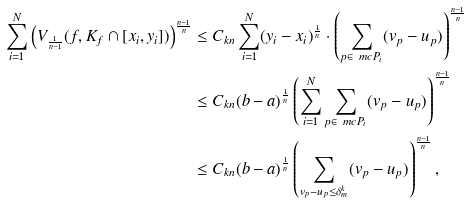<formula> <loc_0><loc_0><loc_500><loc_500>\sum ^ { N } _ { i = 1 } \left ( V _ { \frac { 1 } { n - 1 } } ( f , K _ { f } \cap [ x _ { i } , y _ { i } ] ) \right ) ^ { \frac { n - 1 } { n } } & \leq C _ { k n } \sum ^ { N } _ { i = 1 } ( y _ { i } - x _ { i } ) ^ { \frac { 1 } { n } } \cdot \left ( \sum _ { p \in \ m c P _ { i } } ( v _ { p } - u _ { p } ) \right ) ^ { \frac { n - 1 } { n } } \\ & \leq C _ { k n } ( b - a ) ^ { \frac { 1 } { n } } \left ( \sum ^ { N } _ { i = 1 } \sum _ { p \in \ m c P _ { i } } ( v _ { p } - u _ { p } ) \right ) ^ { \frac { n - 1 } { n } } \\ & \leq C _ { k n } ( b - a ) ^ { \frac { 1 } { n } } \left ( \sum _ { v _ { p } - u _ { p } \leq \delta ^ { k } _ { m } } ( v _ { p } - u _ { p } ) \right ) ^ { \frac { n - 1 } { n } } ,</formula> 